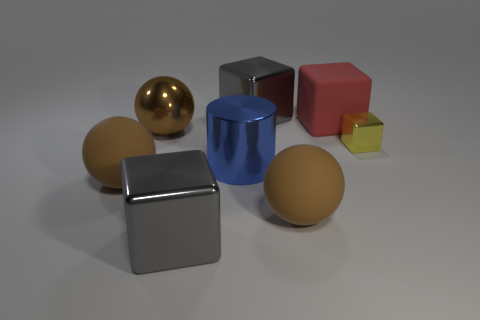Can you describe the different materials represented by the objects in the image? Certainly! The image depicts objects with various materials: a reflective gold sphere suggesting a metallic finish, a matte red cube probably made of plastic, a shiny blue cylinder with a metallic sheen, a textured gray cube resembling brushed metal, and a small glossy yellow cube that looks like glass or a polished stone due to its translucency and reflection. 